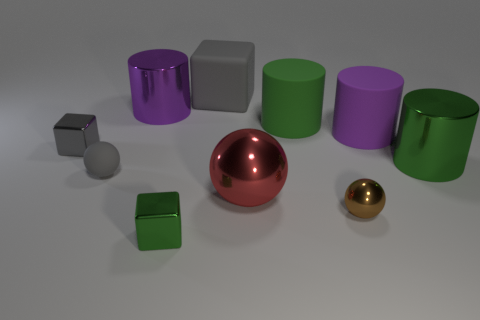The small matte object that is the same color as the matte block is what shape?
Offer a very short reply. Sphere. There is a purple object to the right of the tiny brown shiny object in front of the large cylinder that is on the left side of the big ball; what shape is it?
Your response must be concise. Cylinder. Is the number of green rubber cylinders that are right of the big red ball the same as the number of small gray shiny blocks?
Your response must be concise. Yes. What size is the rubber object that is the same color as the tiny matte ball?
Offer a terse response. Large. Do the red metal thing and the brown shiny thing have the same shape?
Keep it short and to the point. Yes. How many objects are things behind the large purple metallic thing or tiny purple metallic cylinders?
Provide a short and direct response. 1. Are there an equal number of tiny green metallic things that are behind the small gray block and purple rubber cylinders to the left of the purple metal cylinder?
Offer a terse response. Yes. How many other objects are the same shape as the red shiny thing?
Provide a succinct answer. 2. There is a sphere that is to the left of the big cube; does it have the same size as the purple cylinder right of the matte cube?
Your response must be concise. No. How many spheres are red objects or big green matte things?
Offer a terse response. 1. 